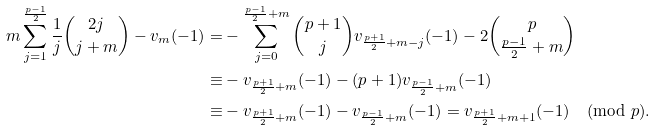<formula> <loc_0><loc_0><loc_500><loc_500>m \sum _ { j = 1 } ^ { \frac { p - 1 } { 2 } } \frac { 1 } { j } \binom { 2 j } { j + m } - v _ { m } ( - 1 ) = & - \sum _ { j = 0 } ^ { \frac { p - 1 } { 2 } + m } \binom { p + 1 } { j } v _ { \frac { p + 1 } { 2 } + m - j } ( - 1 ) - 2 \binom { p } { \frac { p - 1 } { 2 } + m } \\ \equiv & - v _ { \frac { p + 1 } { 2 } + m } ( - 1 ) - ( p + 1 ) v _ { \frac { p - 1 } { 2 } + m } ( - 1 ) \\ \equiv & - v _ { \frac { p + 1 } { 2 } + m } ( - 1 ) - v _ { \frac { p - 1 } { 2 } + m } ( - 1 ) = v _ { \frac { p + 1 } { 2 } + m + 1 } ( - 1 ) \pmod { p } .</formula> 